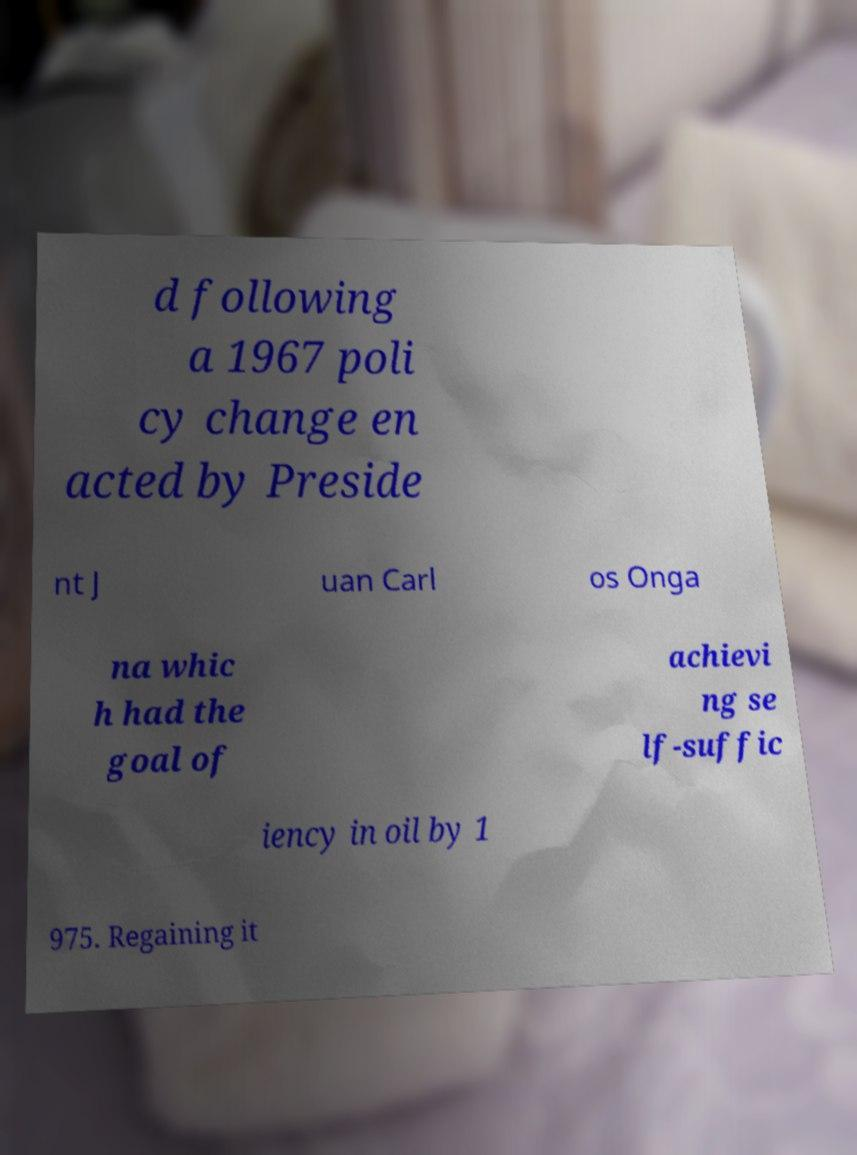Please identify and transcribe the text found in this image. d following a 1967 poli cy change en acted by Preside nt J uan Carl os Onga na whic h had the goal of achievi ng se lf-suffic iency in oil by 1 975. Regaining it 